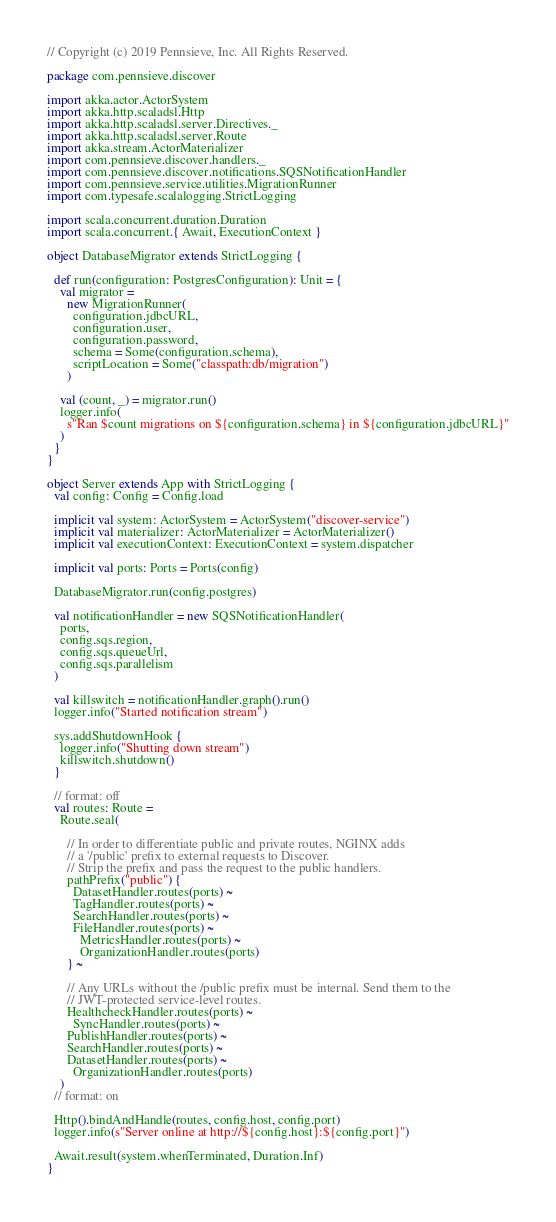Convert code to text. <code><loc_0><loc_0><loc_500><loc_500><_Scala_>// Copyright (c) 2019 Pennsieve, Inc. All Rights Reserved.

package com.pennsieve.discover

import akka.actor.ActorSystem
import akka.http.scaladsl.Http
import akka.http.scaladsl.server.Directives._
import akka.http.scaladsl.server.Route
import akka.stream.ActorMaterializer
import com.pennsieve.discover.handlers._
import com.pennsieve.discover.notifications.SQSNotificationHandler
import com.pennsieve.service.utilities.MigrationRunner
import com.typesafe.scalalogging.StrictLogging

import scala.concurrent.duration.Duration
import scala.concurrent.{ Await, ExecutionContext }

object DatabaseMigrator extends StrictLogging {

  def run(configuration: PostgresConfiguration): Unit = {
    val migrator =
      new MigrationRunner(
        configuration.jdbcURL,
        configuration.user,
        configuration.password,
        schema = Some(configuration.schema),
        scriptLocation = Some("classpath:db/migration")
      )

    val (count, _) = migrator.run()
    logger.info(
      s"Ran $count migrations on ${configuration.schema} in ${configuration.jdbcURL}"
    )
  }
}

object Server extends App with StrictLogging {
  val config: Config = Config.load

  implicit val system: ActorSystem = ActorSystem("discover-service")
  implicit val materializer: ActorMaterializer = ActorMaterializer()
  implicit val executionContext: ExecutionContext = system.dispatcher

  implicit val ports: Ports = Ports(config)

  DatabaseMigrator.run(config.postgres)

  val notificationHandler = new SQSNotificationHandler(
    ports,
    config.sqs.region,
    config.sqs.queueUrl,
    config.sqs.parallelism
  )

  val killswitch = notificationHandler.graph().run()
  logger.info("Started notification stream")

  sys.addShutdownHook {
    logger.info("Shutting down stream")
    killswitch.shutdown()
  }

  // format: off
  val routes: Route =
    Route.seal(

      // In order to differentiate public and private routes, NGINX adds
      // a '/public' prefix to external requests to Discover.
      // Strip the prefix and pass the request to the public handlers.
      pathPrefix("public") {
        DatasetHandler.routes(ports) ~
        TagHandler.routes(ports) ~
        SearchHandler.routes(ports) ~
        FileHandler.routes(ports) ~
          MetricsHandler.routes(ports) ~
          OrganizationHandler.routes(ports)
      } ~

      // Any URLs without the /public prefix must be internal. Send them to the
      // JWT-protected service-level routes.
      HealthcheckHandler.routes(ports) ~
        SyncHandler.routes(ports) ~
      PublishHandler.routes(ports) ~
      SearchHandler.routes(ports) ~
      DatasetHandler.routes(ports) ~
        OrganizationHandler.routes(ports)
    )
  // format: on

  Http().bindAndHandle(routes, config.host, config.port)
  logger.info(s"Server online at http://${config.host}:${config.port}")

  Await.result(system.whenTerminated, Duration.Inf)
}
</code> 